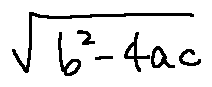Convert formula to latex. <formula><loc_0><loc_0><loc_500><loc_500>\sqrt { b ^ { 2 } - 4 a c }</formula> 